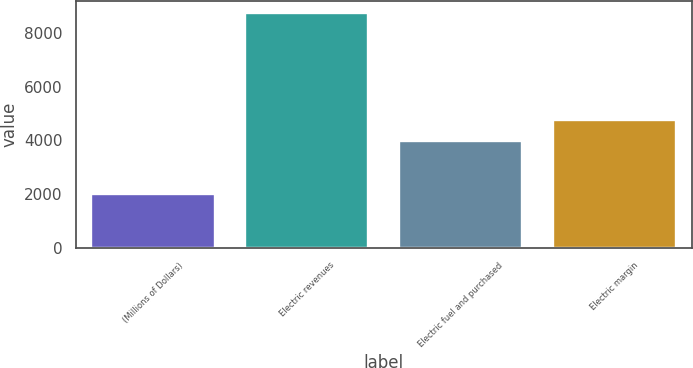Convert chart to OTSL. <chart><loc_0><loc_0><loc_500><loc_500><bar_chart><fcel>(Millions of Dollars)<fcel>Electric revenues<fcel>Electric fuel and purchased<fcel>Electric margin<nl><fcel>2011<fcel>8767<fcel>3992<fcel>4775<nl></chart> 